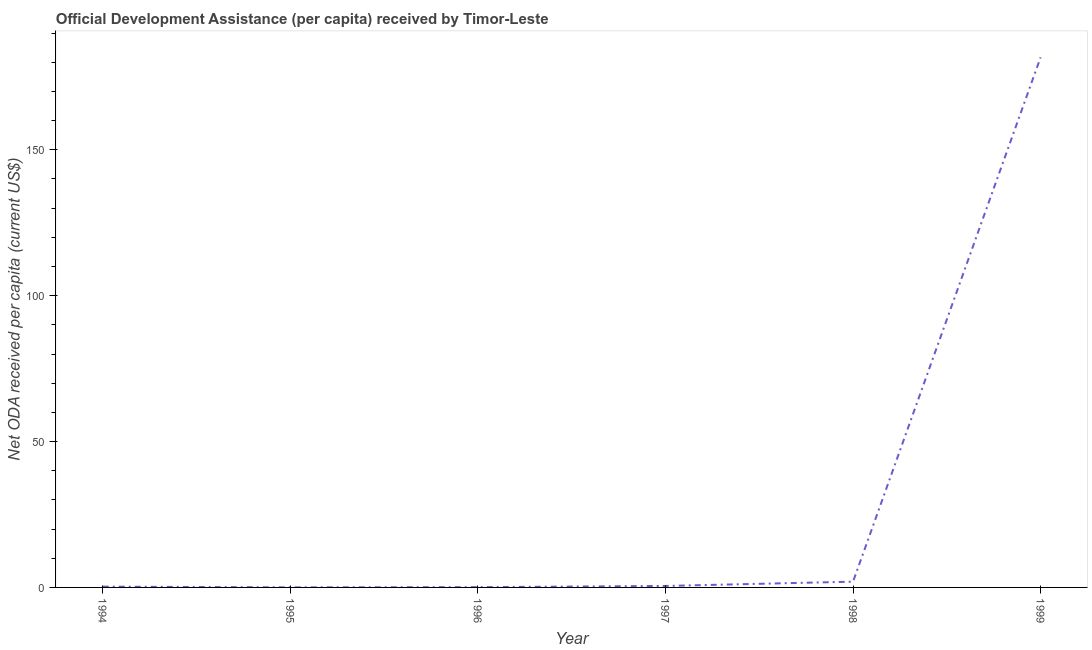What is the net oda received per capita in 1998?
Keep it short and to the point. 1.98. Across all years, what is the maximum net oda received per capita?
Your answer should be compact. 181.7. Across all years, what is the minimum net oda received per capita?
Provide a succinct answer. 0.02. In which year was the net oda received per capita maximum?
Make the answer very short. 1999. What is the sum of the net oda received per capita?
Keep it short and to the point. 184.57. What is the difference between the net oda received per capita in 1995 and 1996?
Provide a succinct answer. -0.07. What is the average net oda received per capita per year?
Your answer should be very brief. 30.76. What is the median net oda received per capita?
Ensure brevity in your answer.  0.39. What is the ratio of the net oda received per capita in 1994 to that in 1999?
Offer a terse response. 0. Is the net oda received per capita in 1996 less than that in 1998?
Keep it short and to the point. Yes. What is the difference between the highest and the second highest net oda received per capita?
Provide a short and direct response. 179.72. What is the difference between the highest and the lowest net oda received per capita?
Give a very brief answer. 181.68. Does the net oda received per capita monotonically increase over the years?
Make the answer very short. No. How many lines are there?
Provide a succinct answer. 1. How many years are there in the graph?
Offer a terse response. 6. What is the difference between two consecutive major ticks on the Y-axis?
Offer a terse response. 50. Are the values on the major ticks of Y-axis written in scientific E-notation?
Provide a short and direct response. No. Does the graph contain any zero values?
Ensure brevity in your answer.  No. Does the graph contain grids?
Ensure brevity in your answer.  No. What is the title of the graph?
Ensure brevity in your answer.  Official Development Assistance (per capita) received by Timor-Leste. What is the label or title of the X-axis?
Offer a terse response. Year. What is the label or title of the Y-axis?
Keep it short and to the point. Net ODA received per capita (current US$). What is the Net ODA received per capita (current US$) of 1994?
Ensure brevity in your answer.  0.27. What is the Net ODA received per capita (current US$) of 1995?
Provide a short and direct response. 0.02. What is the Net ODA received per capita (current US$) in 1996?
Offer a terse response. 0.09. What is the Net ODA received per capita (current US$) in 1997?
Ensure brevity in your answer.  0.5. What is the Net ODA received per capita (current US$) of 1998?
Offer a very short reply. 1.98. What is the Net ODA received per capita (current US$) in 1999?
Offer a very short reply. 181.7. What is the difference between the Net ODA received per capita (current US$) in 1994 and 1995?
Offer a very short reply. 0.25. What is the difference between the Net ODA received per capita (current US$) in 1994 and 1996?
Give a very brief answer. 0.18. What is the difference between the Net ODA received per capita (current US$) in 1994 and 1997?
Make the answer very short. -0.23. What is the difference between the Net ODA received per capita (current US$) in 1994 and 1998?
Provide a succinct answer. -1.7. What is the difference between the Net ODA received per capita (current US$) in 1994 and 1999?
Keep it short and to the point. -181.43. What is the difference between the Net ODA received per capita (current US$) in 1995 and 1996?
Offer a very short reply. -0.07. What is the difference between the Net ODA received per capita (current US$) in 1995 and 1997?
Your answer should be compact. -0.48. What is the difference between the Net ODA received per capita (current US$) in 1995 and 1998?
Provide a short and direct response. -1.95. What is the difference between the Net ODA received per capita (current US$) in 1995 and 1999?
Give a very brief answer. -181.68. What is the difference between the Net ODA received per capita (current US$) in 1996 and 1997?
Your answer should be compact. -0.41. What is the difference between the Net ODA received per capita (current US$) in 1996 and 1998?
Your answer should be compact. -1.88. What is the difference between the Net ODA received per capita (current US$) in 1996 and 1999?
Your answer should be very brief. -181.61. What is the difference between the Net ODA received per capita (current US$) in 1997 and 1998?
Your answer should be compact. -1.47. What is the difference between the Net ODA received per capita (current US$) in 1997 and 1999?
Provide a short and direct response. -181.2. What is the difference between the Net ODA received per capita (current US$) in 1998 and 1999?
Ensure brevity in your answer.  -179.72. What is the ratio of the Net ODA received per capita (current US$) in 1994 to that in 1995?
Offer a terse response. 11.69. What is the ratio of the Net ODA received per capita (current US$) in 1994 to that in 1996?
Make the answer very short. 2.93. What is the ratio of the Net ODA received per capita (current US$) in 1994 to that in 1997?
Provide a succinct answer. 0.54. What is the ratio of the Net ODA received per capita (current US$) in 1994 to that in 1998?
Offer a very short reply. 0.14. What is the ratio of the Net ODA received per capita (current US$) in 1994 to that in 1999?
Make the answer very short. 0. What is the ratio of the Net ODA received per capita (current US$) in 1995 to that in 1996?
Ensure brevity in your answer.  0.25. What is the ratio of the Net ODA received per capita (current US$) in 1995 to that in 1997?
Offer a terse response. 0.05. What is the ratio of the Net ODA received per capita (current US$) in 1995 to that in 1998?
Your answer should be compact. 0.01. What is the ratio of the Net ODA received per capita (current US$) in 1996 to that in 1997?
Your response must be concise. 0.18. What is the ratio of the Net ODA received per capita (current US$) in 1996 to that in 1998?
Your response must be concise. 0.05. What is the ratio of the Net ODA received per capita (current US$) in 1997 to that in 1998?
Your response must be concise. 0.26. What is the ratio of the Net ODA received per capita (current US$) in 1997 to that in 1999?
Offer a very short reply. 0. What is the ratio of the Net ODA received per capita (current US$) in 1998 to that in 1999?
Make the answer very short. 0.01. 